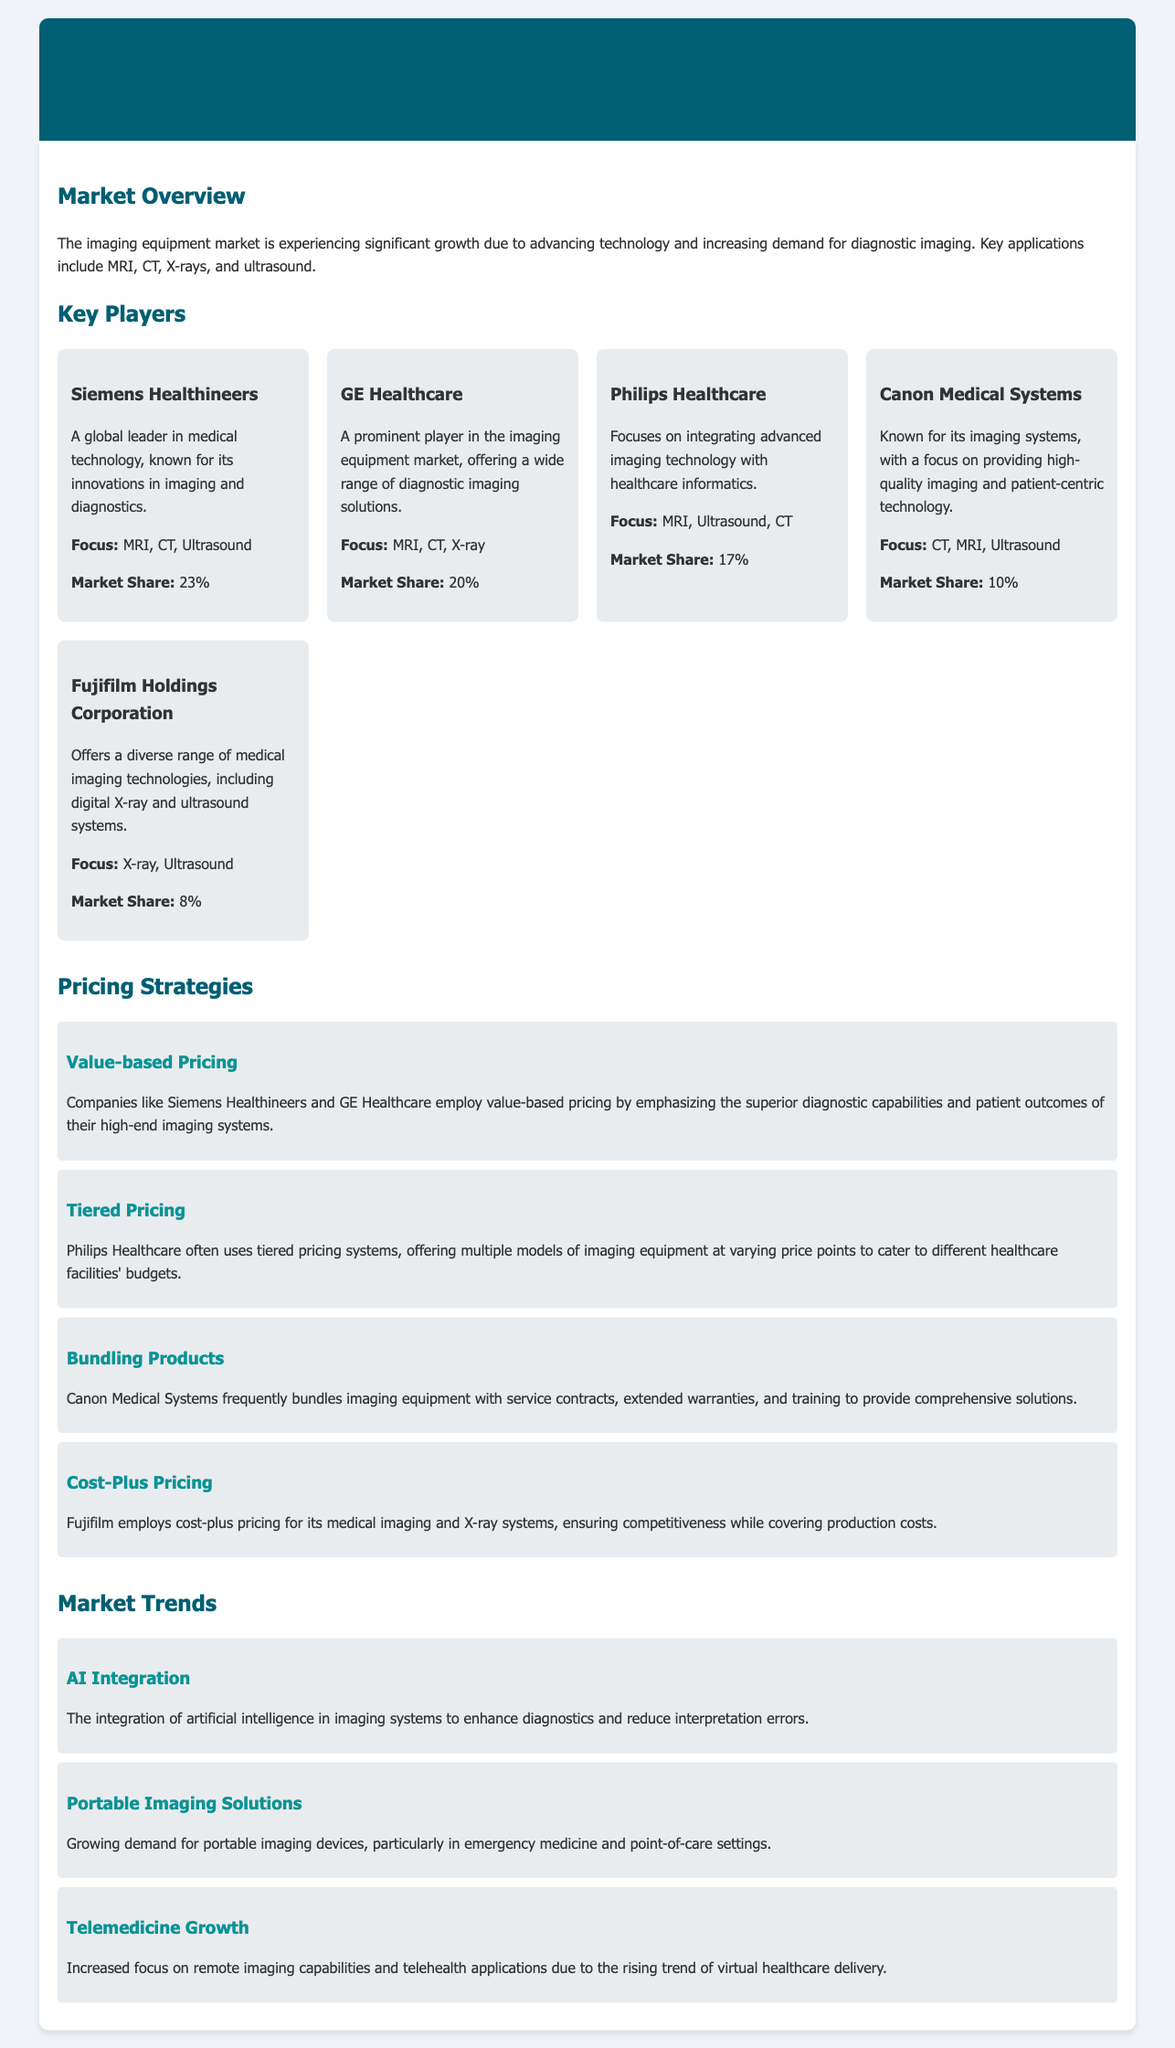What is the market share of Siemens Healthineers? The market share of Siemens Healthineers is provided directly in the document, which states it is 23%.
Answer: 23% Which company focuses on integrating advanced imaging technology with healthcare informatics? The document mentions that Philips Healthcare focuses on integrating advanced imaging technology with healthcare informatics.
Answer: Philips Healthcare What pricing strategy does Canon Medical Systems frequently use? The document notes that Canon Medical Systems frequently bundles imaging equipment with service contracts, extended warranties, and training.
Answer: Bundling Products What is the primary focus of Fujifilm Holdings Corporation? The document indicates that Fujifilm offers a diverse range of medical imaging technologies, including digital X-ray and ultrasound systems.
Answer: X-ray, Ultrasound How many key players are listed in the document? The document enumerates five key players in the imaging equipment market.
Answer: Five Which trend involves enhancing diagnostics with technology? The document mentions the integration of artificial intelligence in imaging systems to enhance diagnostics and reduce interpretation errors.
Answer: AI Integration What is the focus of GE Healthcare? According to the document, GE Healthcare's focus includes MRI, CT, and X-ray technologies.
Answer: MRI, CT, X-ray How does Philips Healthcare cater to different healthcare facilities' budgets? The document describes that Philips Healthcare employs tiered pricing systems to accommodate varying budgets.
Answer: Tiered Pricing 